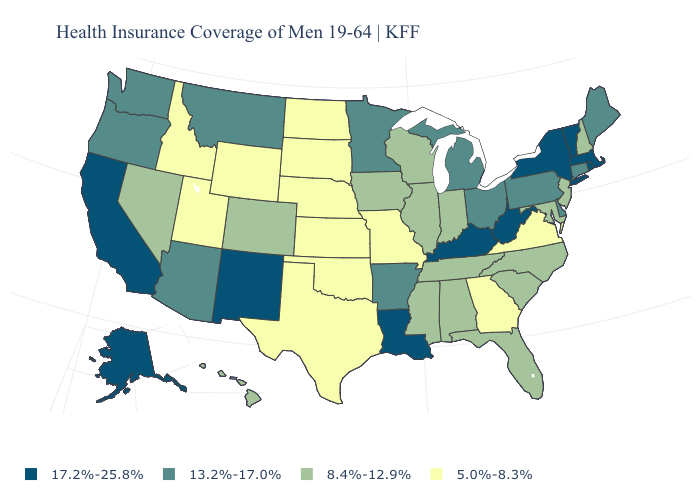What is the value of Connecticut?
Concise answer only. 13.2%-17.0%. Does the map have missing data?
Keep it brief. No. Does Michigan have the highest value in the MidWest?
Be succinct. Yes. Does Maryland have the same value as North Dakota?
Be succinct. No. What is the highest value in the USA?
Give a very brief answer. 17.2%-25.8%. What is the highest value in the USA?
Concise answer only. 17.2%-25.8%. Among the states that border Massachusetts , which have the highest value?
Keep it brief. New York, Rhode Island, Vermont. Among the states that border Arizona , does California have the lowest value?
Give a very brief answer. No. Among the states that border North Dakota , which have the lowest value?
Short answer required. South Dakota. Does New Mexico have a lower value than Nevada?
Answer briefly. No. What is the value of Montana?
Answer briefly. 13.2%-17.0%. What is the lowest value in states that border North Carolina?
Give a very brief answer. 5.0%-8.3%. Among the states that border California , does Nevada have the lowest value?
Keep it brief. Yes. Name the states that have a value in the range 5.0%-8.3%?
Write a very short answer. Georgia, Idaho, Kansas, Missouri, Nebraska, North Dakota, Oklahoma, South Dakota, Texas, Utah, Virginia, Wyoming. Does North Dakota have the same value as Georgia?
Give a very brief answer. Yes. 